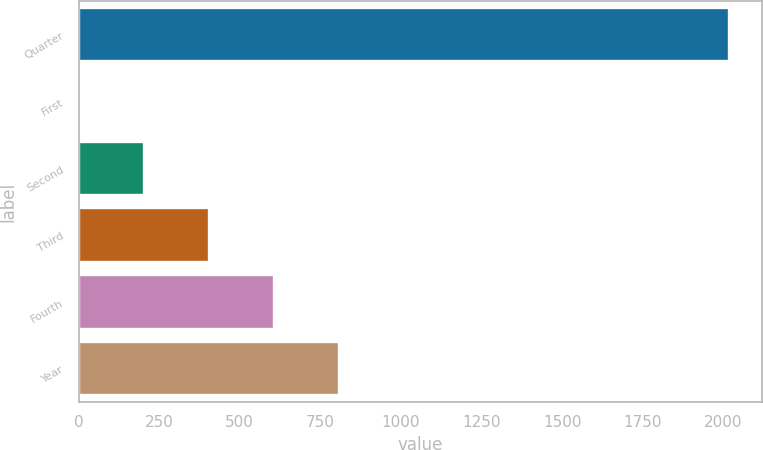Convert chart. <chart><loc_0><loc_0><loc_500><loc_500><bar_chart><fcel>Quarter<fcel>First<fcel>Second<fcel>Third<fcel>Fourth<fcel>Year<nl><fcel>2018<fcel>2<fcel>203.6<fcel>405.2<fcel>606.8<fcel>808.4<nl></chart> 